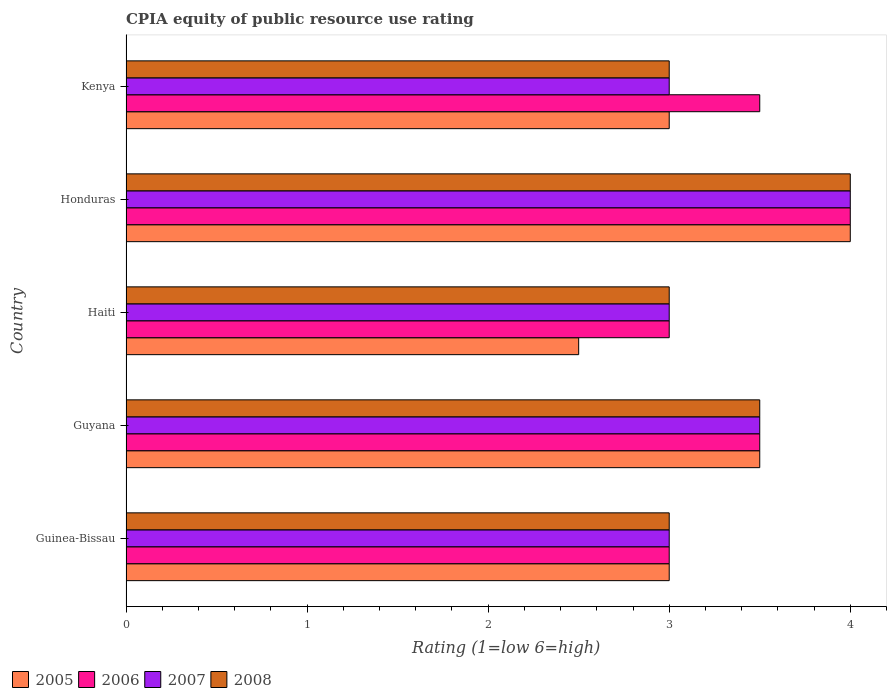How many bars are there on the 4th tick from the top?
Your answer should be compact. 4. How many bars are there on the 5th tick from the bottom?
Provide a succinct answer. 4. What is the label of the 3rd group of bars from the top?
Ensure brevity in your answer.  Haiti. What is the CPIA rating in 2006 in Kenya?
Offer a very short reply. 3.5. Across all countries, what is the maximum CPIA rating in 2005?
Ensure brevity in your answer.  4. Across all countries, what is the minimum CPIA rating in 2006?
Your answer should be compact. 3. In which country was the CPIA rating in 2005 maximum?
Keep it short and to the point. Honduras. In which country was the CPIA rating in 2007 minimum?
Your answer should be very brief. Guinea-Bissau. What is the total CPIA rating in 2007 in the graph?
Provide a succinct answer. 16.5. What is the ratio of the CPIA rating in 2007 in Guyana to that in Haiti?
Provide a short and direct response. 1.17. Is the CPIA rating in 2006 in Guinea-Bissau less than that in Kenya?
Your answer should be very brief. Yes. Is the difference between the CPIA rating in 2006 in Haiti and Kenya greater than the difference between the CPIA rating in 2005 in Haiti and Kenya?
Make the answer very short. No. Is the sum of the CPIA rating in 2007 in Guyana and Haiti greater than the maximum CPIA rating in 2005 across all countries?
Make the answer very short. Yes. Is it the case that in every country, the sum of the CPIA rating in 2005 and CPIA rating in 2008 is greater than the CPIA rating in 2007?
Ensure brevity in your answer.  Yes. How many countries are there in the graph?
Your answer should be very brief. 5. What is the difference between two consecutive major ticks on the X-axis?
Provide a succinct answer. 1. Does the graph contain grids?
Ensure brevity in your answer.  No. Where does the legend appear in the graph?
Offer a terse response. Bottom left. How are the legend labels stacked?
Keep it short and to the point. Horizontal. What is the title of the graph?
Provide a succinct answer. CPIA equity of public resource use rating. What is the label or title of the X-axis?
Your response must be concise. Rating (1=low 6=high). What is the label or title of the Y-axis?
Provide a short and direct response. Country. What is the Rating (1=low 6=high) of 2005 in Guinea-Bissau?
Give a very brief answer. 3. What is the Rating (1=low 6=high) of 2008 in Guinea-Bissau?
Give a very brief answer. 3. What is the Rating (1=low 6=high) in 2005 in Guyana?
Offer a very short reply. 3.5. What is the Rating (1=low 6=high) of 2006 in Guyana?
Make the answer very short. 3.5. What is the Rating (1=low 6=high) of 2005 in Haiti?
Provide a succinct answer. 2.5. What is the Rating (1=low 6=high) of 2006 in Haiti?
Keep it short and to the point. 3. What is the Rating (1=low 6=high) of 2007 in Haiti?
Provide a short and direct response. 3. What is the Rating (1=low 6=high) of 2008 in Haiti?
Your answer should be compact. 3. What is the Rating (1=low 6=high) in 2006 in Honduras?
Your answer should be very brief. 4. What is the Rating (1=low 6=high) in 2008 in Honduras?
Give a very brief answer. 4. What is the Rating (1=low 6=high) in 2008 in Kenya?
Offer a very short reply. 3. Across all countries, what is the maximum Rating (1=low 6=high) of 2005?
Give a very brief answer. 4. Across all countries, what is the maximum Rating (1=low 6=high) of 2008?
Provide a short and direct response. 4. Across all countries, what is the minimum Rating (1=low 6=high) of 2005?
Make the answer very short. 2.5. Across all countries, what is the minimum Rating (1=low 6=high) of 2007?
Keep it short and to the point. 3. What is the total Rating (1=low 6=high) in 2005 in the graph?
Provide a short and direct response. 16. What is the total Rating (1=low 6=high) of 2006 in the graph?
Your response must be concise. 17. What is the total Rating (1=low 6=high) of 2007 in the graph?
Keep it short and to the point. 16.5. What is the difference between the Rating (1=low 6=high) of 2005 in Guinea-Bissau and that in Guyana?
Make the answer very short. -0.5. What is the difference between the Rating (1=low 6=high) of 2006 in Guinea-Bissau and that in Guyana?
Your response must be concise. -0.5. What is the difference between the Rating (1=low 6=high) in 2008 in Guinea-Bissau and that in Guyana?
Offer a terse response. -0.5. What is the difference between the Rating (1=low 6=high) in 2005 in Guinea-Bissau and that in Haiti?
Your answer should be compact. 0.5. What is the difference between the Rating (1=low 6=high) of 2006 in Guinea-Bissau and that in Haiti?
Ensure brevity in your answer.  0. What is the difference between the Rating (1=low 6=high) in 2007 in Guinea-Bissau and that in Haiti?
Ensure brevity in your answer.  0. What is the difference between the Rating (1=low 6=high) in 2008 in Guinea-Bissau and that in Haiti?
Offer a very short reply. 0. What is the difference between the Rating (1=low 6=high) of 2007 in Guinea-Bissau and that in Honduras?
Give a very brief answer. -1. What is the difference between the Rating (1=low 6=high) of 2008 in Guinea-Bissau and that in Honduras?
Your answer should be compact. -1. What is the difference between the Rating (1=low 6=high) of 2006 in Guinea-Bissau and that in Kenya?
Your answer should be very brief. -0.5. What is the difference between the Rating (1=low 6=high) of 2007 in Guinea-Bissau and that in Kenya?
Make the answer very short. 0. What is the difference between the Rating (1=low 6=high) of 2005 in Guyana and that in Haiti?
Ensure brevity in your answer.  1. What is the difference between the Rating (1=low 6=high) of 2006 in Guyana and that in Haiti?
Provide a succinct answer. 0.5. What is the difference between the Rating (1=low 6=high) in 2007 in Guyana and that in Kenya?
Your response must be concise. 0.5. What is the difference between the Rating (1=low 6=high) of 2008 in Guyana and that in Kenya?
Offer a very short reply. 0.5. What is the difference between the Rating (1=low 6=high) of 2005 in Haiti and that in Honduras?
Your answer should be very brief. -1.5. What is the difference between the Rating (1=low 6=high) of 2006 in Haiti and that in Honduras?
Make the answer very short. -1. What is the difference between the Rating (1=low 6=high) of 2007 in Haiti and that in Honduras?
Your answer should be very brief. -1. What is the difference between the Rating (1=low 6=high) of 2008 in Haiti and that in Honduras?
Make the answer very short. -1. What is the difference between the Rating (1=low 6=high) in 2007 in Haiti and that in Kenya?
Offer a very short reply. 0. What is the difference between the Rating (1=low 6=high) in 2008 in Haiti and that in Kenya?
Make the answer very short. 0. What is the difference between the Rating (1=low 6=high) of 2005 in Honduras and that in Kenya?
Offer a terse response. 1. What is the difference between the Rating (1=low 6=high) in 2006 in Honduras and that in Kenya?
Provide a short and direct response. 0.5. What is the difference between the Rating (1=low 6=high) of 2007 in Honduras and that in Kenya?
Keep it short and to the point. 1. What is the difference between the Rating (1=low 6=high) of 2005 in Guinea-Bissau and the Rating (1=low 6=high) of 2007 in Guyana?
Provide a succinct answer. -0.5. What is the difference between the Rating (1=low 6=high) of 2006 in Guinea-Bissau and the Rating (1=low 6=high) of 2007 in Guyana?
Give a very brief answer. -0.5. What is the difference between the Rating (1=low 6=high) in 2006 in Guinea-Bissau and the Rating (1=low 6=high) in 2008 in Guyana?
Ensure brevity in your answer.  -0.5. What is the difference between the Rating (1=low 6=high) of 2007 in Guinea-Bissau and the Rating (1=low 6=high) of 2008 in Guyana?
Make the answer very short. -0.5. What is the difference between the Rating (1=low 6=high) in 2005 in Guinea-Bissau and the Rating (1=low 6=high) in 2006 in Haiti?
Provide a short and direct response. 0. What is the difference between the Rating (1=low 6=high) in 2006 in Guinea-Bissau and the Rating (1=low 6=high) in 2008 in Haiti?
Give a very brief answer. 0. What is the difference between the Rating (1=low 6=high) of 2007 in Guinea-Bissau and the Rating (1=low 6=high) of 2008 in Haiti?
Provide a succinct answer. 0. What is the difference between the Rating (1=low 6=high) of 2005 in Guinea-Bissau and the Rating (1=low 6=high) of 2007 in Honduras?
Ensure brevity in your answer.  -1. What is the difference between the Rating (1=low 6=high) of 2005 in Guinea-Bissau and the Rating (1=low 6=high) of 2008 in Honduras?
Your answer should be compact. -1. What is the difference between the Rating (1=low 6=high) in 2006 in Guinea-Bissau and the Rating (1=low 6=high) in 2008 in Honduras?
Give a very brief answer. -1. What is the difference between the Rating (1=low 6=high) in 2006 in Guinea-Bissau and the Rating (1=low 6=high) in 2007 in Kenya?
Keep it short and to the point. 0. What is the difference between the Rating (1=low 6=high) of 2006 in Guinea-Bissau and the Rating (1=low 6=high) of 2008 in Kenya?
Your response must be concise. 0. What is the difference between the Rating (1=low 6=high) of 2005 in Guyana and the Rating (1=low 6=high) of 2008 in Haiti?
Offer a terse response. 0.5. What is the difference between the Rating (1=low 6=high) in 2006 in Guyana and the Rating (1=low 6=high) in 2007 in Haiti?
Provide a short and direct response. 0.5. What is the difference between the Rating (1=low 6=high) of 2007 in Guyana and the Rating (1=low 6=high) of 2008 in Haiti?
Your answer should be compact. 0.5. What is the difference between the Rating (1=low 6=high) in 2005 in Guyana and the Rating (1=low 6=high) in 2006 in Honduras?
Your answer should be very brief. -0.5. What is the difference between the Rating (1=low 6=high) in 2005 in Guyana and the Rating (1=low 6=high) in 2007 in Honduras?
Provide a short and direct response. -0.5. What is the difference between the Rating (1=low 6=high) in 2006 in Guyana and the Rating (1=low 6=high) in 2008 in Honduras?
Ensure brevity in your answer.  -0.5. What is the difference between the Rating (1=low 6=high) of 2007 in Guyana and the Rating (1=low 6=high) of 2008 in Honduras?
Your answer should be very brief. -0.5. What is the difference between the Rating (1=low 6=high) of 2005 in Guyana and the Rating (1=low 6=high) of 2006 in Kenya?
Your answer should be compact. 0. What is the difference between the Rating (1=low 6=high) of 2005 in Guyana and the Rating (1=low 6=high) of 2008 in Kenya?
Give a very brief answer. 0.5. What is the difference between the Rating (1=low 6=high) of 2006 in Guyana and the Rating (1=low 6=high) of 2007 in Kenya?
Provide a succinct answer. 0.5. What is the difference between the Rating (1=low 6=high) of 2006 in Guyana and the Rating (1=low 6=high) of 2008 in Kenya?
Offer a very short reply. 0.5. What is the difference between the Rating (1=low 6=high) of 2007 in Guyana and the Rating (1=low 6=high) of 2008 in Kenya?
Ensure brevity in your answer.  0.5. What is the difference between the Rating (1=low 6=high) of 2005 in Haiti and the Rating (1=low 6=high) of 2008 in Honduras?
Your answer should be very brief. -1.5. What is the difference between the Rating (1=low 6=high) of 2006 in Haiti and the Rating (1=low 6=high) of 2007 in Honduras?
Make the answer very short. -1. What is the difference between the Rating (1=low 6=high) of 2007 in Haiti and the Rating (1=low 6=high) of 2008 in Honduras?
Give a very brief answer. -1. What is the difference between the Rating (1=low 6=high) of 2005 in Haiti and the Rating (1=low 6=high) of 2006 in Kenya?
Keep it short and to the point. -1. What is the difference between the Rating (1=low 6=high) in 2006 in Haiti and the Rating (1=low 6=high) in 2007 in Kenya?
Keep it short and to the point. 0. What is the difference between the Rating (1=low 6=high) in 2006 in Haiti and the Rating (1=low 6=high) in 2008 in Kenya?
Provide a short and direct response. 0. What is the difference between the Rating (1=low 6=high) of 2005 in Honduras and the Rating (1=low 6=high) of 2008 in Kenya?
Give a very brief answer. 1. What is the difference between the Rating (1=low 6=high) in 2007 in Honduras and the Rating (1=low 6=high) in 2008 in Kenya?
Give a very brief answer. 1. What is the average Rating (1=low 6=high) of 2005 per country?
Keep it short and to the point. 3.2. What is the average Rating (1=low 6=high) in 2006 per country?
Ensure brevity in your answer.  3.4. What is the average Rating (1=low 6=high) in 2008 per country?
Your answer should be compact. 3.3. What is the difference between the Rating (1=low 6=high) in 2005 and Rating (1=low 6=high) in 2006 in Guinea-Bissau?
Your answer should be compact. 0. What is the difference between the Rating (1=low 6=high) in 2005 and Rating (1=low 6=high) in 2007 in Guinea-Bissau?
Your answer should be very brief. 0. What is the difference between the Rating (1=low 6=high) of 2006 and Rating (1=low 6=high) of 2008 in Guinea-Bissau?
Give a very brief answer. 0. What is the difference between the Rating (1=low 6=high) in 2005 and Rating (1=low 6=high) in 2006 in Guyana?
Provide a succinct answer. 0. What is the difference between the Rating (1=low 6=high) of 2005 and Rating (1=low 6=high) of 2007 in Guyana?
Offer a very short reply. 0. What is the difference between the Rating (1=low 6=high) of 2006 and Rating (1=low 6=high) of 2007 in Guyana?
Keep it short and to the point. 0. What is the difference between the Rating (1=low 6=high) in 2007 and Rating (1=low 6=high) in 2008 in Guyana?
Provide a succinct answer. 0. What is the difference between the Rating (1=low 6=high) of 2005 and Rating (1=low 6=high) of 2008 in Haiti?
Offer a terse response. -0.5. What is the difference between the Rating (1=low 6=high) of 2007 and Rating (1=low 6=high) of 2008 in Haiti?
Your answer should be compact. 0. What is the difference between the Rating (1=low 6=high) in 2006 and Rating (1=low 6=high) in 2007 in Honduras?
Keep it short and to the point. 0. What is the difference between the Rating (1=low 6=high) of 2007 and Rating (1=low 6=high) of 2008 in Honduras?
Ensure brevity in your answer.  0. What is the difference between the Rating (1=low 6=high) of 2005 and Rating (1=low 6=high) of 2006 in Kenya?
Your response must be concise. -0.5. What is the difference between the Rating (1=low 6=high) in 2007 and Rating (1=low 6=high) in 2008 in Kenya?
Ensure brevity in your answer.  0. What is the ratio of the Rating (1=low 6=high) of 2005 in Guinea-Bissau to that in Guyana?
Give a very brief answer. 0.86. What is the ratio of the Rating (1=low 6=high) of 2007 in Guinea-Bissau to that in Guyana?
Your answer should be compact. 0.86. What is the ratio of the Rating (1=low 6=high) in 2008 in Guinea-Bissau to that in Guyana?
Your answer should be very brief. 0.86. What is the ratio of the Rating (1=low 6=high) of 2008 in Guinea-Bissau to that in Haiti?
Your response must be concise. 1. What is the ratio of the Rating (1=low 6=high) in 2005 in Guinea-Bissau to that in Honduras?
Your response must be concise. 0.75. What is the ratio of the Rating (1=low 6=high) of 2007 in Guinea-Bissau to that in Honduras?
Give a very brief answer. 0.75. What is the ratio of the Rating (1=low 6=high) of 2008 in Guinea-Bissau to that in Honduras?
Keep it short and to the point. 0.75. What is the ratio of the Rating (1=low 6=high) of 2006 in Guinea-Bissau to that in Kenya?
Provide a succinct answer. 0.86. What is the ratio of the Rating (1=low 6=high) of 2008 in Guinea-Bissau to that in Kenya?
Your response must be concise. 1. What is the ratio of the Rating (1=low 6=high) in 2005 in Guyana to that in Haiti?
Provide a succinct answer. 1.4. What is the ratio of the Rating (1=low 6=high) in 2006 in Guyana to that in Haiti?
Make the answer very short. 1.17. What is the ratio of the Rating (1=low 6=high) in 2006 in Guyana to that in Honduras?
Give a very brief answer. 0.88. What is the ratio of the Rating (1=low 6=high) of 2005 in Guyana to that in Kenya?
Your response must be concise. 1.17. What is the ratio of the Rating (1=low 6=high) in 2006 in Guyana to that in Kenya?
Ensure brevity in your answer.  1. What is the ratio of the Rating (1=low 6=high) in 2008 in Guyana to that in Kenya?
Offer a terse response. 1.17. What is the ratio of the Rating (1=low 6=high) of 2006 in Haiti to that in Honduras?
Make the answer very short. 0.75. What is the ratio of the Rating (1=low 6=high) in 2007 in Haiti to that in Honduras?
Make the answer very short. 0.75. What is the ratio of the Rating (1=low 6=high) in 2008 in Haiti to that in Honduras?
Give a very brief answer. 0.75. What is the ratio of the Rating (1=low 6=high) in 2006 in Haiti to that in Kenya?
Your answer should be compact. 0.86. What is the ratio of the Rating (1=low 6=high) of 2007 in Haiti to that in Kenya?
Give a very brief answer. 1. What is the ratio of the Rating (1=low 6=high) of 2008 in Haiti to that in Kenya?
Ensure brevity in your answer.  1. What is the difference between the highest and the second highest Rating (1=low 6=high) of 2006?
Your response must be concise. 0.5. What is the difference between the highest and the lowest Rating (1=low 6=high) of 2005?
Your answer should be very brief. 1.5. What is the difference between the highest and the lowest Rating (1=low 6=high) of 2006?
Your response must be concise. 1. What is the difference between the highest and the lowest Rating (1=low 6=high) of 2007?
Ensure brevity in your answer.  1. What is the difference between the highest and the lowest Rating (1=low 6=high) of 2008?
Provide a short and direct response. 1. 